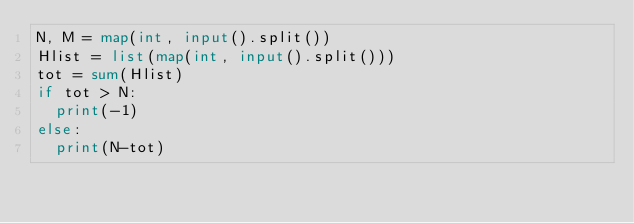Convert code to text. <code><loc_0><loc_0><loc_500><loc_500><_Python_>N, M = map(int, input().split())
Hlist = list(map(int, input().split())) 
tot = sum(Hlist)
if tot > N:
  print(-1)
else:
  print(N-tot)</code> 